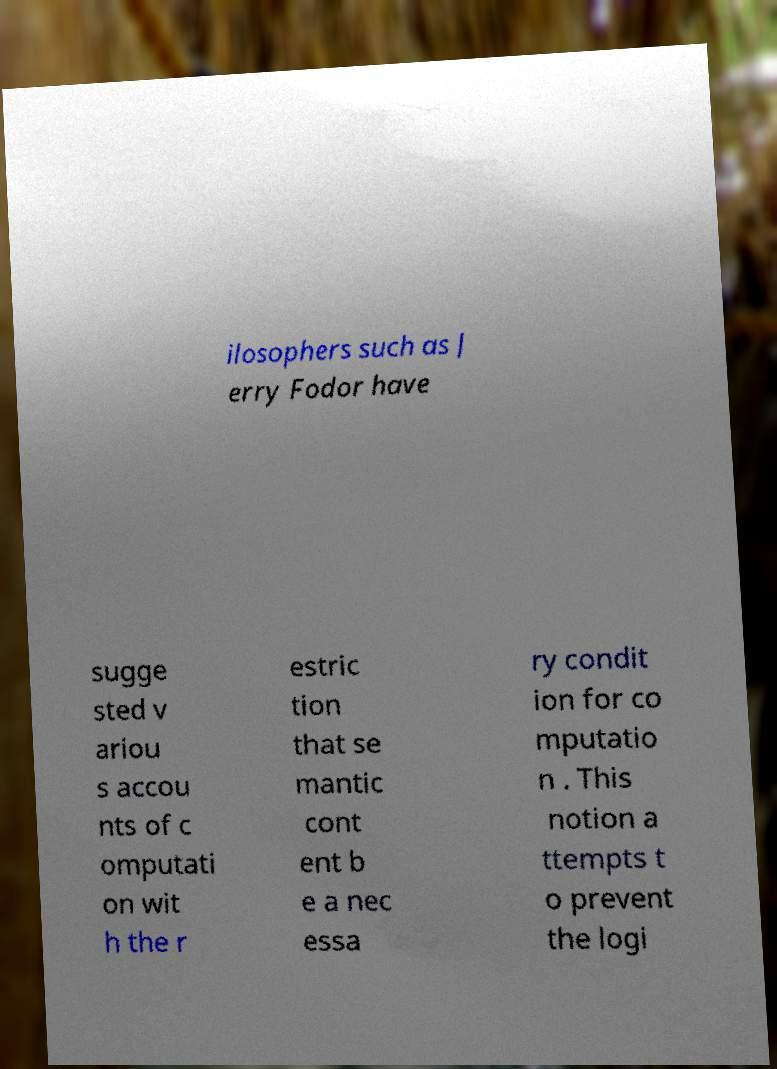Could you extract and type out the text from this image? ilosophers such as J erry Fodor have sugge sted v ariou s accou nts of c omputati on wit h the r estric tion that se mantic cont ent b e a nec essa ry condit ion for co mputatio n . This notion a ttempts t o prevent the logi 